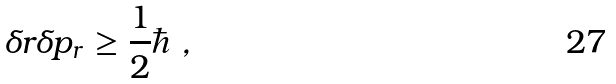<formula> <loc_0><loc_0><loc_500><loc_500>\delta r \delta p _ { r } \geq \frac { 1 } { 2 } \hbar { \ } ,</formula> 